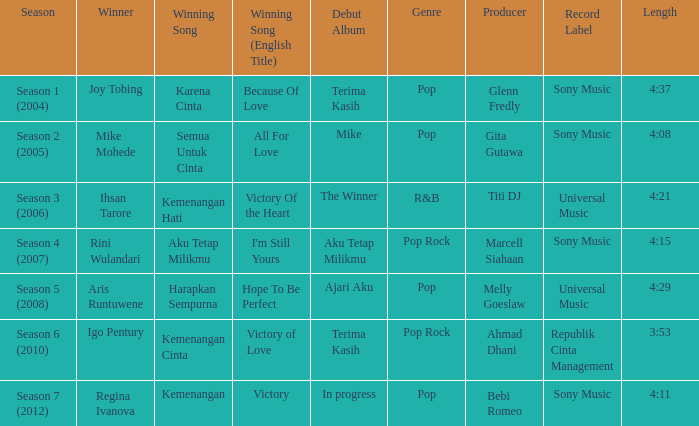Which winning song had a debut album in progress? Kemenangan. Give me the full table as a dictionary. {'header': ['Season', 'Winner', 'Winning Song', 'Winning Song (English Title)', 'Debut Album', 'Genre', 'Producer', 'Record Label', 'Length'], 'rows': [['Season 1 (2004)', 'Joy Tobing', 'Karena Cinta', 'Because Of Love', 'Terima Kasih', 'Pop', 'Glenn Fredly', 'Sony Music', '4:37'], ['Season 2 (2005)', 'Mike Mohede', 'Semua Untuk Cinta', 'All For Love', 'Mike', 'Pop', 'Gita Gutawa', 'Sony Music', '4:08'], ['Season 3 (2006)', 'Ihsan Tarore', 'Kemenangan Hati', 'Victory Of the Heart', 'The Winner', 'R&B', 'Titi DJ', 'Universal Music', '4:21'], ['Season 4 (2007)', 'Rini Wulandari', 'Aku Tetap Milikmu', "I'm Still Yours", 'Aku Tetap Milikmu', 'Pop Rock', 'Marcell Siahaan', 'Sony Music', '4:15'], ['Season 5 (2008)', 'Aris Runtuwene', 'Harapkan Sempurna', 'Hope To Be Perfect', 'Ajari Aku', 'Pop', 'Melly Goeslaw', 'Universal Music', '4:29'], ['Season 6 (2010)', 'Igo Pentury', 'Kemenangan Cinta', 'Victory of Love', 'Terima Kasih', 'Pop Rock', 'Ahmad Dhani', 'Republik Cinta Management', '3:53'], ['Season 7 (2012)', 'Regina Ivanova', 'Kemenangan', 'Victory', 'In progress', 'Pop', 'Bebi Romeo', 'Sony Music', '4:11']]} 